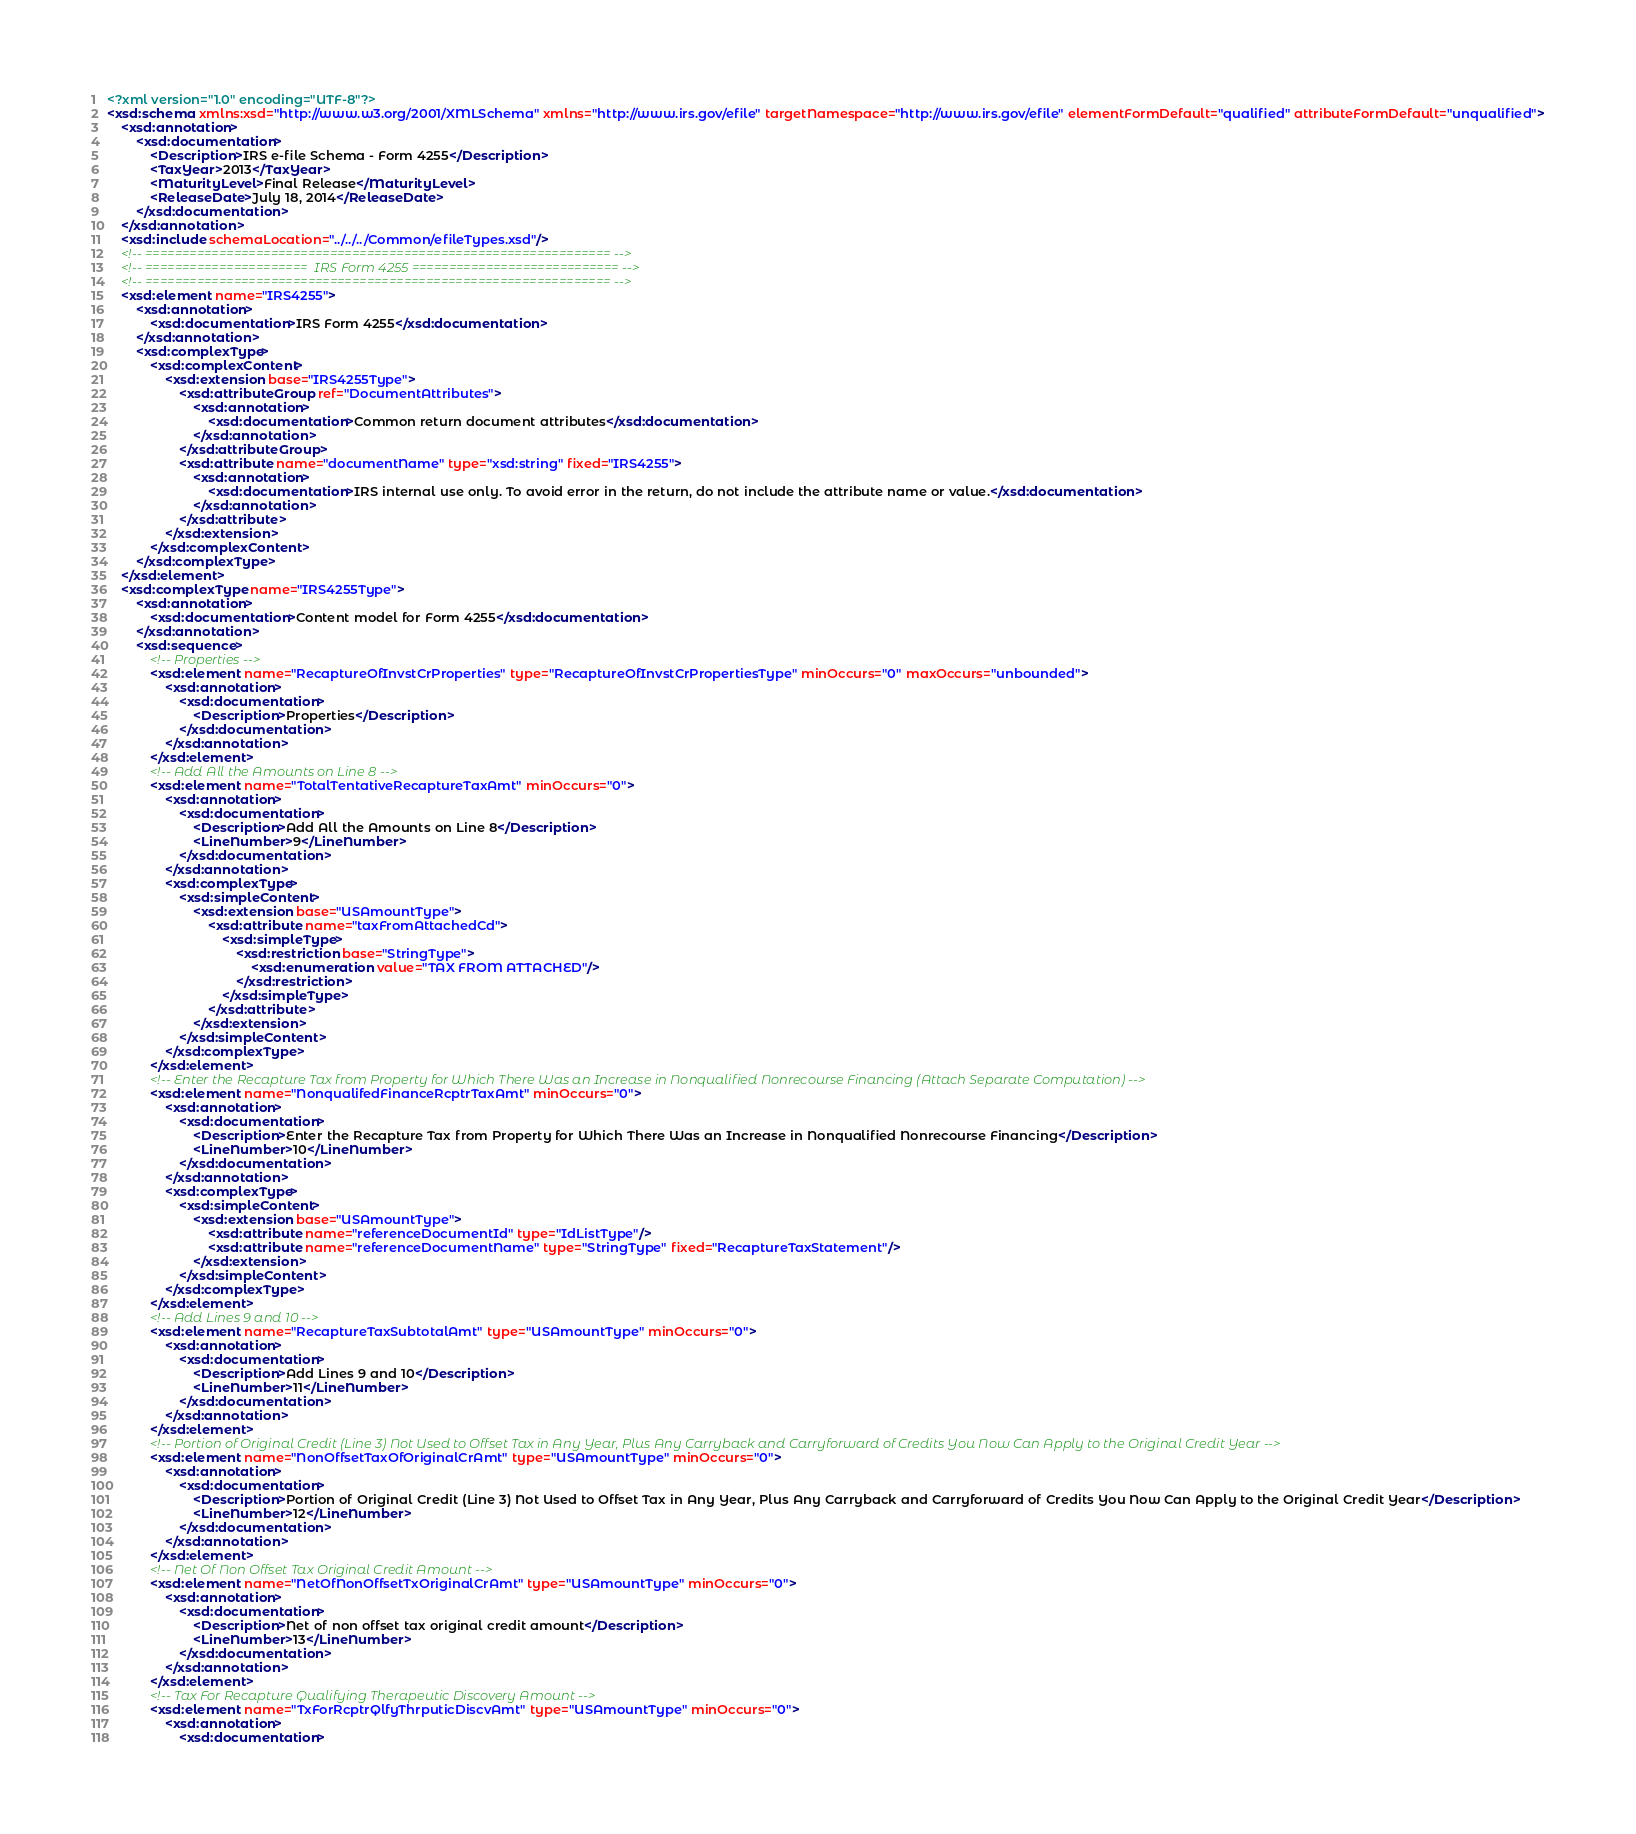<code> <loc_0><loc_0><loc_500><loc_500><_XML_><?xml version="1.0" encoding="UTF-8"?>
<xsd:schema xmlns:xsd="http://www.w3.org/2001/XMLSchema" xmlns="http://www.irs.gov/efile" targetNamespace="http://www.irs.gov/efile" elementFormDefault="qualified" attributeFormDefault="unqualified">
	<xsd:annotation>
		<xsd:documentation>
			<Description>IRS e-file Schema - Form 4255</Description>
			<TaxYear>2013</TaxYear>
			<MaturityLevel>Final Release</MaturityLevel>
			<ReleaseDate>July 18, 2014</ReleaseDate>
		</xsd:documentation>
	</xsd:annotation>
	<xsd:include schemaLocation="../../../Common/efileTypes.xsd"/>
	<!-- =============================================================== -->
	<!-- ======================  IRS Form 4255 ============================ -->
	<!-- =============================================================== -->
	<xsd:element name="IRS4255">
		<xsd:annotation>
			<xsd:documentation>IRS Form 4255</xsd:documentation>
		</xsd:annotation>
		<xsd:complexType>
			<xsd:complexContent>
				<xsd:extension base="IRS4255Type">
					<xsd:attributeGroup ref="DocumentAttributes">
						<xsd:annotation>
							<xsd:documentation>Common return document attributes</xsd:documentation>
						</xsd:annotation>
					</xsd:attributeGroup>
					<xsd:attribute name="documentName" type="xsd:string" fixed="IRS4255">
						<xsd:annotation>
							<xsd:documentation>IRS internal use only. To avoid error in the return, do not include the attribute name or value.</xsd:documentation>
						</xsd:annotation>
					</xsd:attribute>
				</xsd:extension>
			</xsd:complexContent>
		</xsd:complexType>
	</xsd:element>
	<xsd:complexType name="IRS4255Type">
		<xsd:annotation>
			<xsd:documentation>Content model for Form 4255</xsd:documentation>
		</xsd:annotation>
		<xsd:sequence>
			<!-- Properties -->
			<xsd:element name="RecaptureOfInvstCrProperties" type="RecaptureOfInvstCrPropertiesType" minOccurs="0" maxOccurs="unbounded">
				<xsd:annotation>
					<xsd:documentation>
						<Description>Properties</Description>
					</xsd:documentation>
				</xsd:annotation>
			</xsd:element>
			<!-- Add All the Amounts on Line 8 -->
			<xsd:element name="TotalTentativeRecaptureTaxAmt" minOccurs="0">
				<xsd:annotation>
					<xsd:documentation>
						<Description>Add All the Amounts on Line 8</Description>
						<LineNumber>9</LineNumber>
					</xsd:documentation>
				</xsd:annotation>
				<xsd:complexType>
					<xsd:simpleContent>
						<xsd:extension base="USAmountType">
							<xsd:attribute name="taxFromAttachedCd">
								<xsd:simpleType>
									<xsd:restriction base="StringType">
										<xsd:enumeration value="TAX FROM ATTACHED"/>
									</xsd:restriction>
								</xsd:simpleType>
							</xsd:attribute>
						</xsd:extension>
					</xsd:simpleContent>
				</xsd:complexType>
			</xsd:element>
			<!-- Enter the Recapture Tax from Property for Which There Was an Increase in Nonqualified Nonrecourse Financing (Attach Separate Computation) -->
			<xsd:element name="NonqualifedFinanceRcptrTaxAmt" minOccurs="0">
				<xsd:annotation>
					<xsd:documentation>
						<Description>Enter the Recapture Tax from Property for Which There Was an Increase in Nonqualified Nonrecourse Financing</Description>
						<LineNumber>10</LineNumber>
					</xsd:documentation>
				</xsd:annotation>
				<xsd:complexType>
					<xsd:simpleContent>
						<xsd:extension base="USAmountType">
							<xsd:attribute name="referenceDocumentId" type="IdListType"/>
							<xsd:attribute name="referenceDocumentName" type="StringType" fixed="RecaptureTaxStatement"/>
						</xsd:extension>
					</xsd:simpleContent>
				</xsd:complexType>
			</xsd:element>
			<!-- Add Lines 9 and 10 -->
			<xsd:element name="RecaptureTaxSubtotalAmt" type="USAmountType" minOccurs="0">
				<xsd:annotation>
					<xsd:documentation>
						<Description>Add Lines 9 and 10</Description>
						<LineNumber>11</LineNumber>
					</xsd:documentation>
				</xsd:annotation>
			</xsd:element>
			<!-- Portion of Original Credit (Line 3) Not Used to Offset Tax in Any Year, Plus Any Carryback and Carryforward of Credits You Now Can Apply to the Original Credit Year -->
			<xsd:element name="NonOffsetTaxOfOriginalCrAmt" type="USAmountType" minOccurs="0">
				<xsd:annotation>
					<xsd:documentation>
						<Description>Portion of Original Credit (Line 3) Not Used to Offset Tax in Any Year, Plus Any Carryback and Carryforward of Credits You Now Can Apply to the Original Credit Year</Description>
						<LineNumber>12</LineNumber>
					</xsd:documentation>
				</xsd:annotation>
			</xsd:element>
			<!-- Net Of Non Offset Tax Original Credit Amount -->
			<xsd:element name="NetOfNonOffsetTxOriginalCrAmt" type="USAmountType" minOccurs="0">
				<xsd:annotation>
					<xsd:documentation>
						<Description>Net of non offset tax original credit amount</Description>
						<LineNumber>13</LineNumber>
					</xsd:documentation>
				</xsd:annotation>
			</xsd:element>
			<!-- Tax For Recapture Qualifying Therapeutic Discovery Amount -->
			<xsd:element name="TxForRcptrQlfyThrputicDiscvAmt" type="USAmountType" minOccurs="0">
				<xsd:annotation>
					<xsd:documentation></code> 